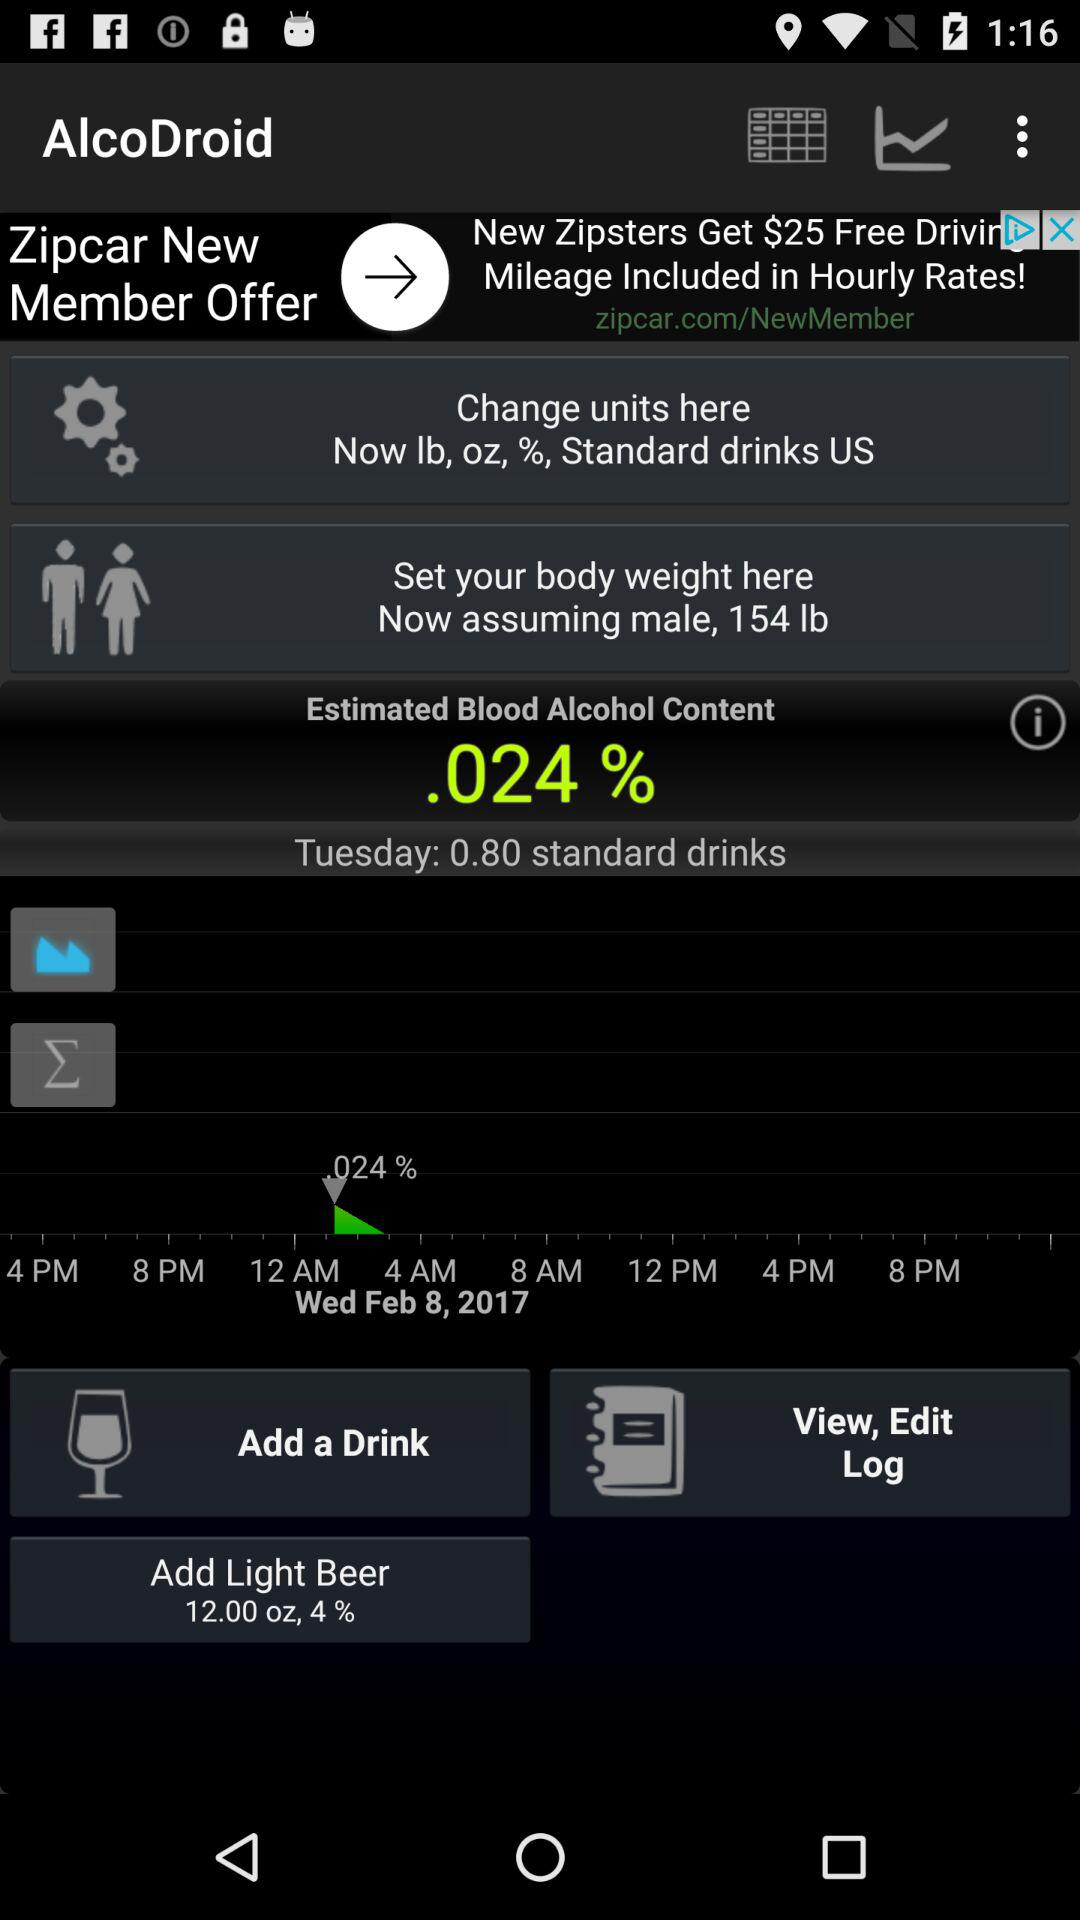What date is it on Wednesday? The date is February 8, 2017. 